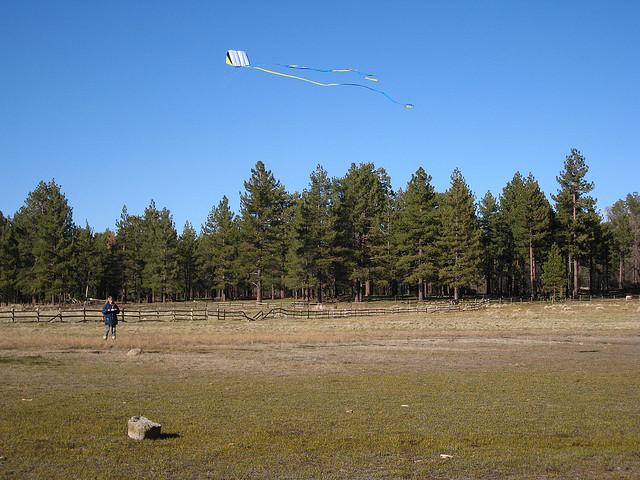Is the sky clear?
Quick response, please. Yes. What kind of trees are in the background?
Answer briefly. Pine. What is this person doing?
Give a very brief answer. Flying kite. 